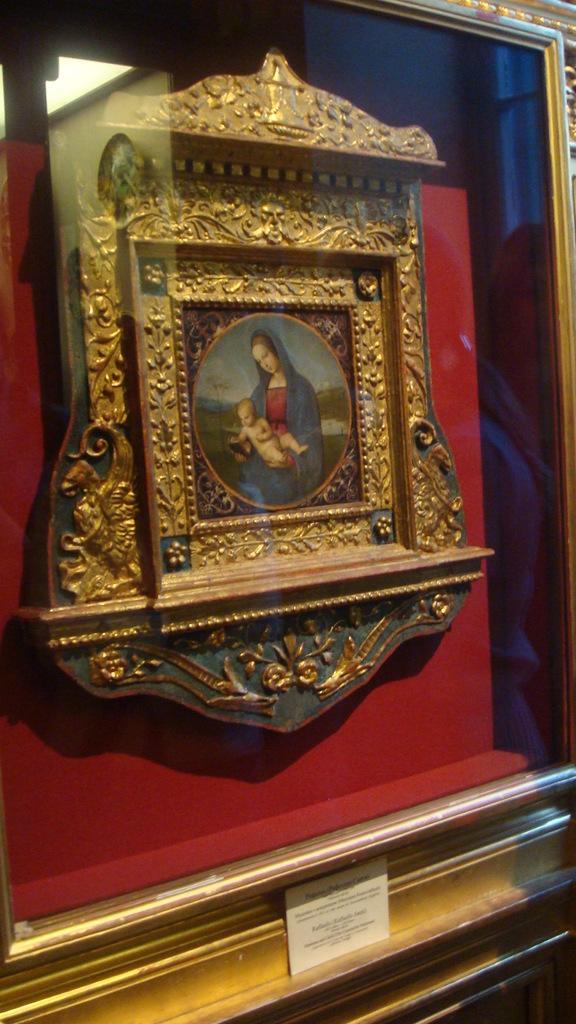In one or two sentences, can you explain what this image depicts? This picture contains a photo frame in which woman wearing blue dress is holding a baby in her hands and in the background, it is red in color. At the bottom of the picture, we see a price tag. 